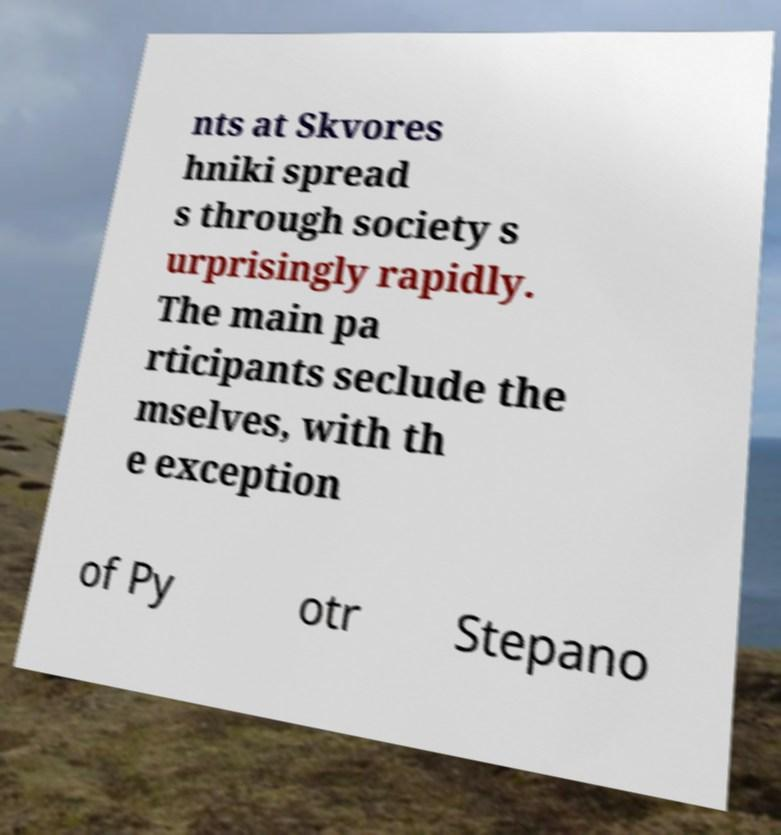Could you assist in decoding the text presented in this image and type it out clearly? nts at Skvores hniki spread s through society s urprisingly rapidly. The main pa rticipants seclude the mselves, with th e exception of Py otr Stepano 